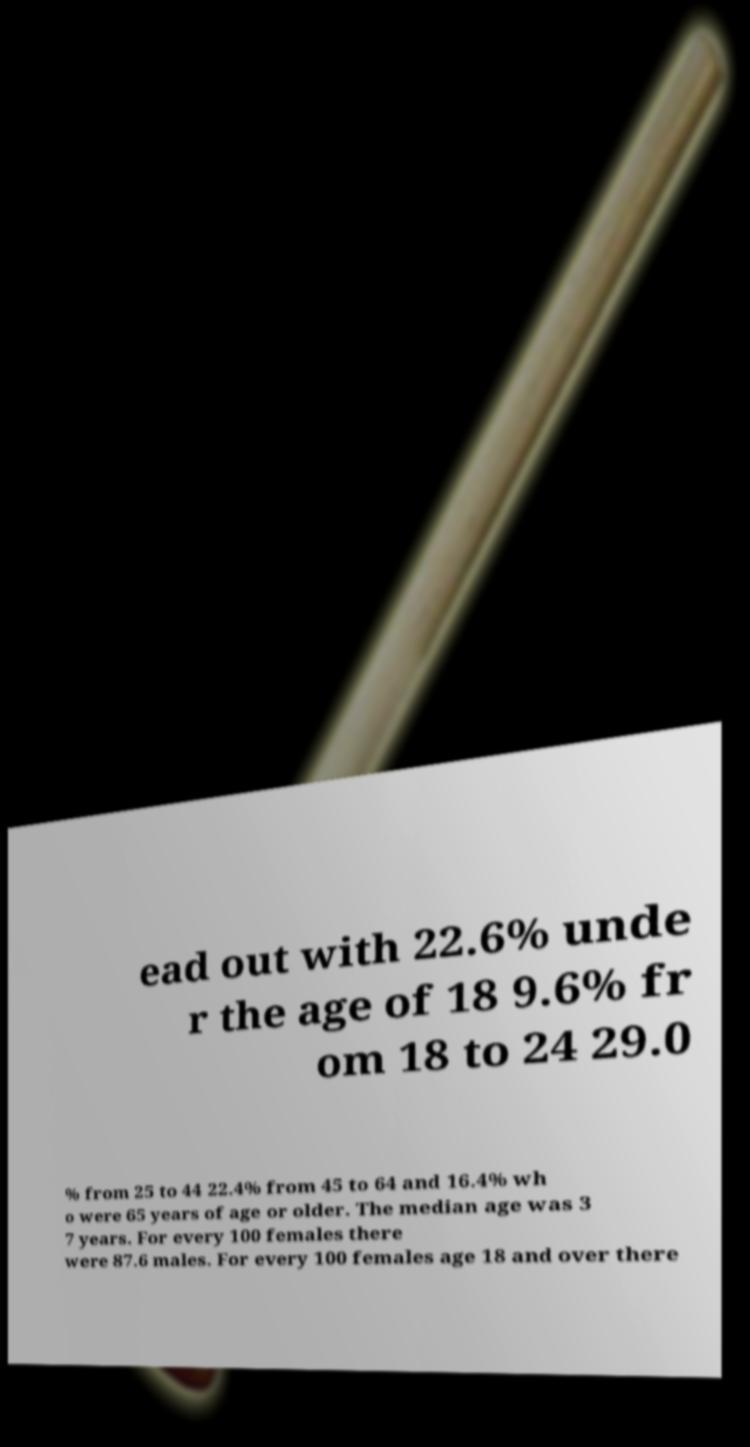There's text embedded in this image that I need extracted. Can you transcribe it verbatim? ead out with 22.6% unde r the age of 18 9.6% fr om 18 to 24 29.0 % from 25 to 44 22.4% from 45 to 64 and 16.4% wh o were 65 years of age or older. The median age was 3 7 years. For every 100 females there were 87.6 males. For every 100 females age 18 and over there 